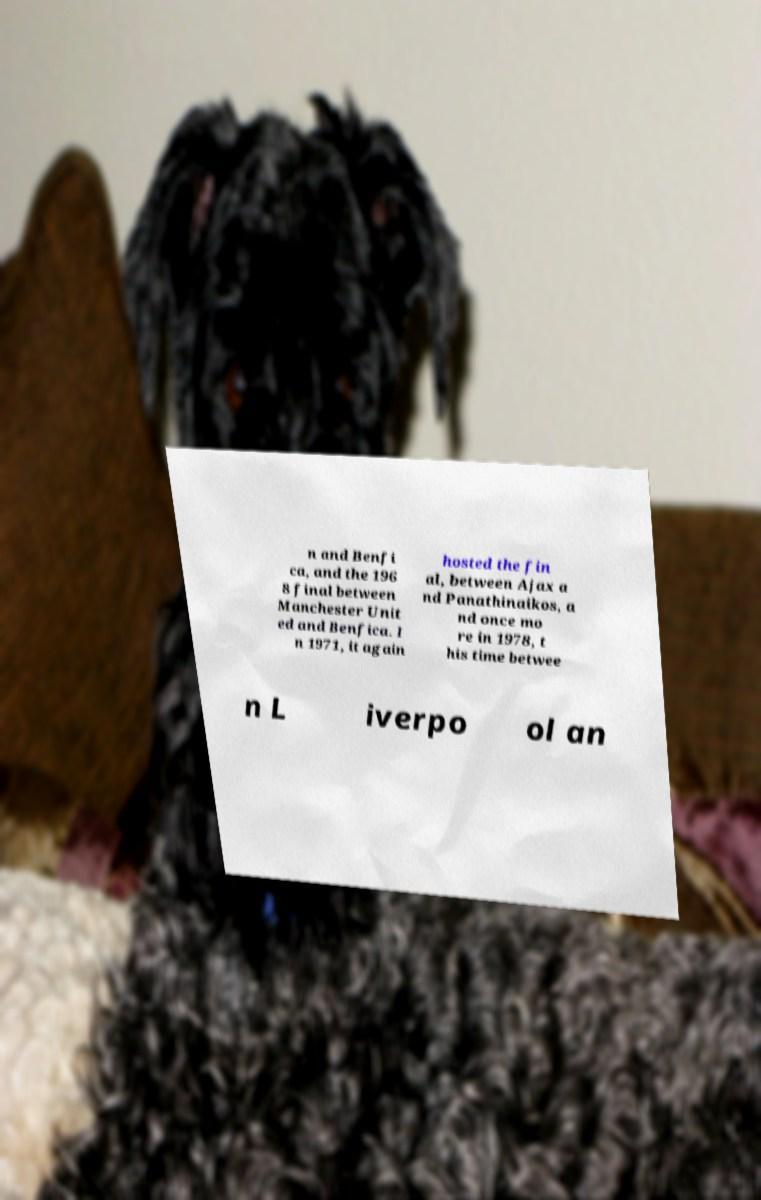Please read and relay the text visible in this image. What does it say? n and Benfi ca, and the 196 8 final between Manchester Unit ed and Benfica. I n 1971, it again hosted the fin al, between Ajax a nd Panathinaikos, a nd once mo re in 1978, t his time betwee n L iverpo ol an 